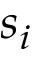<formula> <loc_0><loc_0><loc_500><loc_500>s _ { i }</formula> 